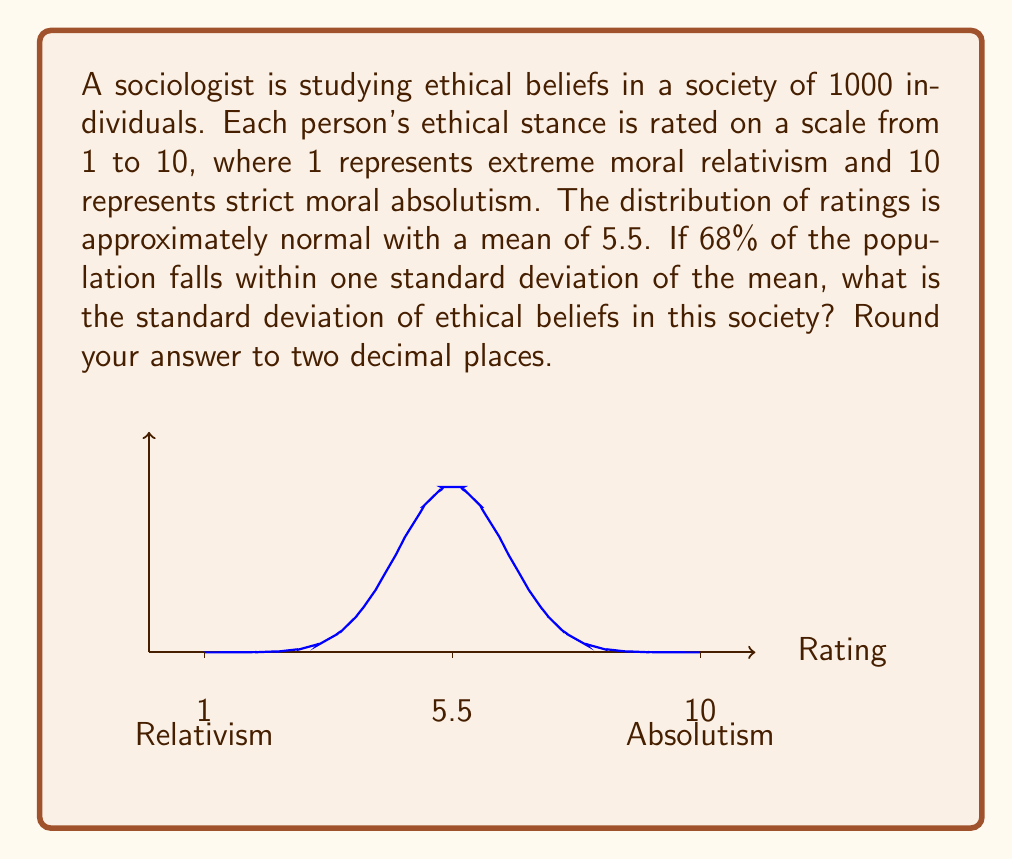Could you help me with this problem? To solve this problem, we'll use the properties of the normal distribution and the given information:

1) For a normal distribution, approximately 68% of the data falls within one standard deviation of the mean.

2) We're given that the mean (μ) is 5.5.

3) Let's denote the standard deviation as σ.

4) In a normal distribution, the interval (μ - σ, μ + σ) contains 68% of the data.

5) We can set up the equation:
   $$(5.5 + \sigma) - (5.5 - \sigma) = 0.68 \times (10 - 1)$$

6) Simplify the left side:
   $$2\sigma = 0.68 \times 9$$

7) Solve for σ:
   $$\sigma = \frac{0.68 \times 9}{2} = \frac{6.12}{2} = 3.06$$

8) Rounding to two decimal places:
   $$\sigma \approx 3.06$$

Thus, the standard deviation of ethical beliefs in this society is approximately 3.06.
Answer: 3.06 